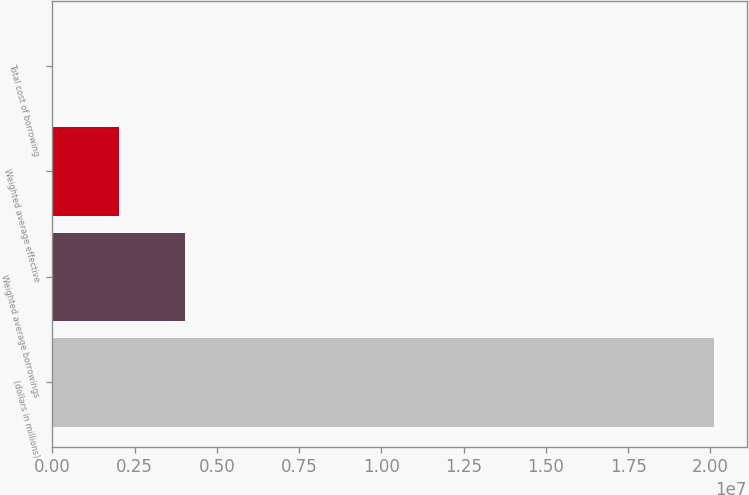Convert chart. <chart><loc_0><loc_0><loc_500><loc_500><bar_chart><fcel>(dollars in millions)<fcel>Weighted average borrowings<fcel>Weighted average effective<fcel>Total cost of borrowing<nl><fcel>2.0102e+07<fcel>4.0204e+06<fcel>2.0102e+06<fcel>0.48<nl></chart> 